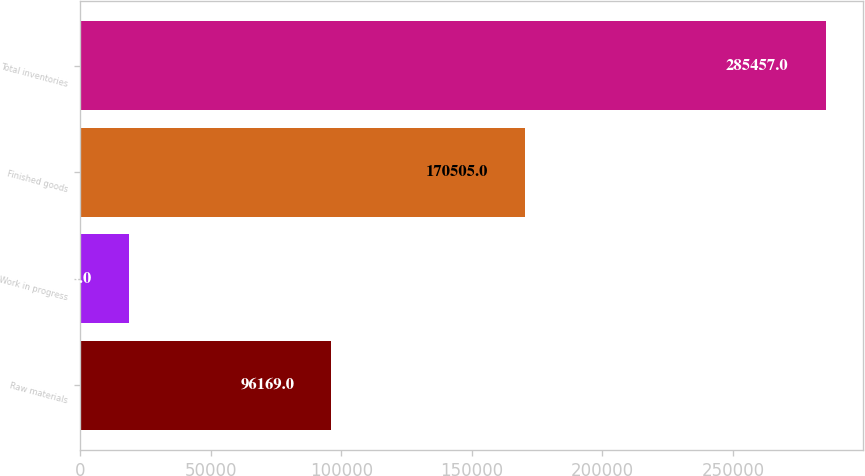Convert chart. <chart><loc_0><loc_0><loc_500><loc_500><bar_chart><fcel>Raw materials<fcel>Work in progress<fcel>Finished goods<fcel>Total inventories<nl><fcel>96169<fcel>18783<fcel>170505<fcel>285457<nl></chart> 